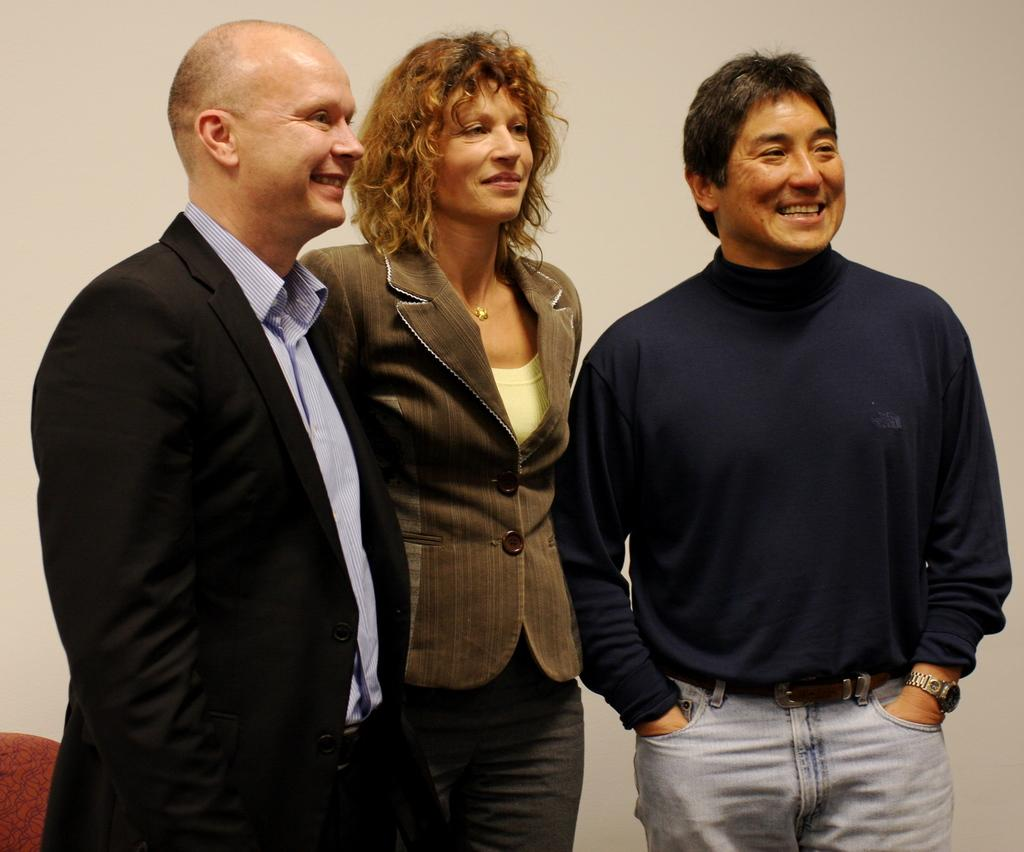What is happening in the image? There are people standing in the image. What can be seen in the background of the image? There is a wall in the background of the image. Where is the zipper located in the image? There is no zipper present in the image. What type of kitten can be seen playing with the people in the image? There is no kitten present in the image; only people are visible. 